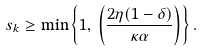<formula> <loc_0><loc_0><loc_500><loc_500>s _ { k } \geq \min \left \{ 1 , \, \left ( \frac { 2 \eta ( 1 - \delta ) } { \kappa \alpha } \right ) \right \} .</formula> 